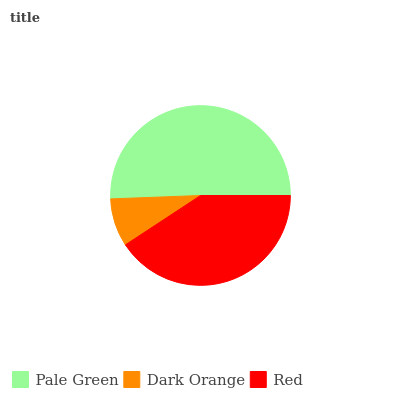Is Dark Orange the minimum?
Answer yes or no. Yes. Is Pale Green the maximum?
Answer yes or no. Yes. Is Red the minimum?
Answer yes or no. No. Is Red the maximum?
Answer yes or no. No. Is Red greater than Dark Orange?
Answer yes or no. Yes. Is Dark Orange less than Red?
Answer yes or no. Yes. Is Dark Orange greater than Red?
Answer yes or no. No. Is Red less than Dark Orange?
Answer yes or no. No. Is Red the high median?
Answer yes or no. Yes. Is Red the low median?
Answer yes or no. Yes. Is Pale Green the high median?
Answer yes or no. No. Is Dark Orange the low median?
Answer yes or no. No. 